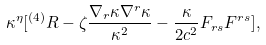Convert formula to latex. <formula><loc_0><loc_0><loc_500><loc_500>\kappa ^ { \eta } [ ^ { ( 4 ) } R - \zeta \frac { \nabla _ { r } \kappa \nabla ^ { r } \kappa } { \kappa ^ { 2 } } - \frac { \kappa } { 2 c ^ { 2 } } F _ { r s } F ^ { r s } ] ,</formula> 